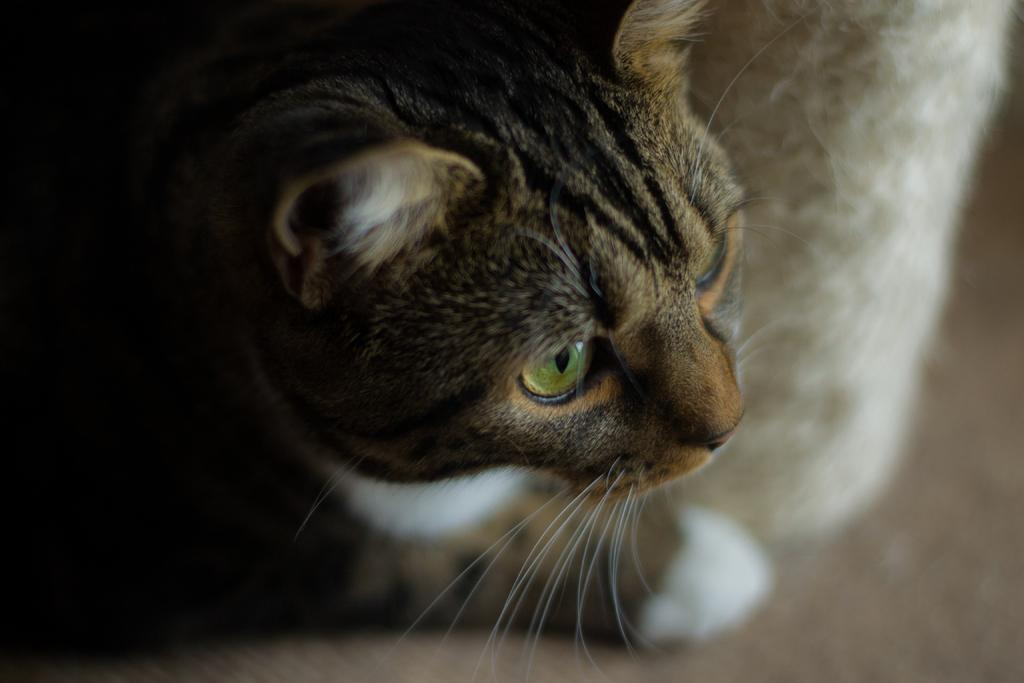What type of animal is in the image? There is a cat in the image. Where is the cat located in the image? The cat is on a surface. What type of building can be seen in the background of the image? There is no building present in the image; it only features a cat on a surface. 